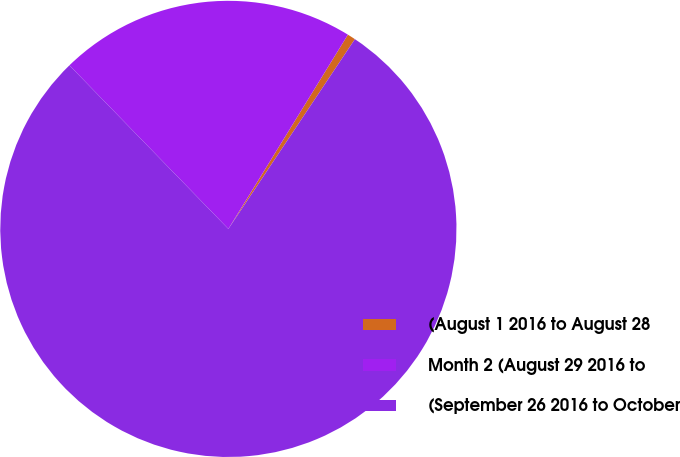Convert chart. <chart><loc_0><loc_0><loc_500><loc_500><pie_chart><fcel>(August 1 2016 to August 28<fcel>Month 2 (August 29 2016 to<fcel>(September 26 2016 to October<nl><fcel>0.58%<fcel>21.05%<fcel>78.36%<nl></chart> 